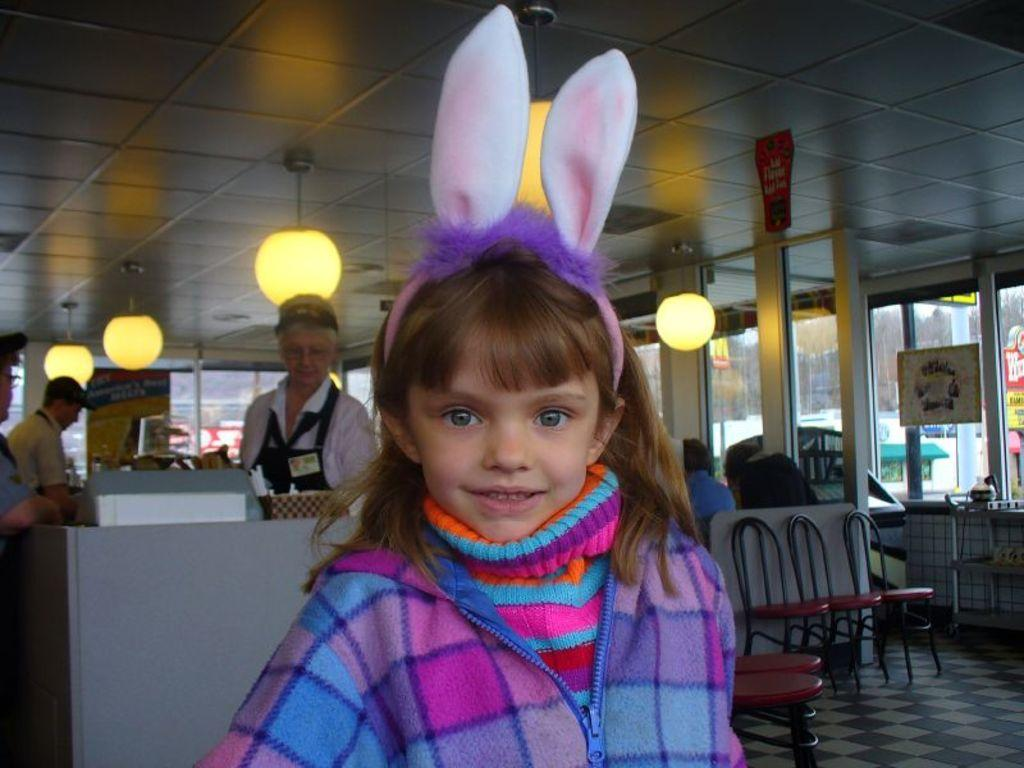What is located on top in the image? There are lights on top in the image. Who can be seen in the image? There are people standing in the image, including a kid wearing a jacket. What type of furniture is visible in the image? There are chairs visible in the image. What type of ink is being used by the people in the image? There is no indication in the image that ink is being used, as the people are standing and not engaging in any activity that would involve ink. 